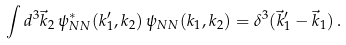<formula> <loc_0><loc_0><loc_500><loc_500>\int d ^ { 3 } \vec { k } _ { 2 } \, \psi _ { N N } ^ { \ast } ( k _ { 1 } ^ { \prime } , k _ { 2 } ) \, \psi _ { N N } ( k _ { 1 } , k _ { 2 } ) = \delta ^ { 3 } ( \vec { k } ^ { \prime } _ { 1 } - \vec { k } _ { 1 } ) \, .</formula> 